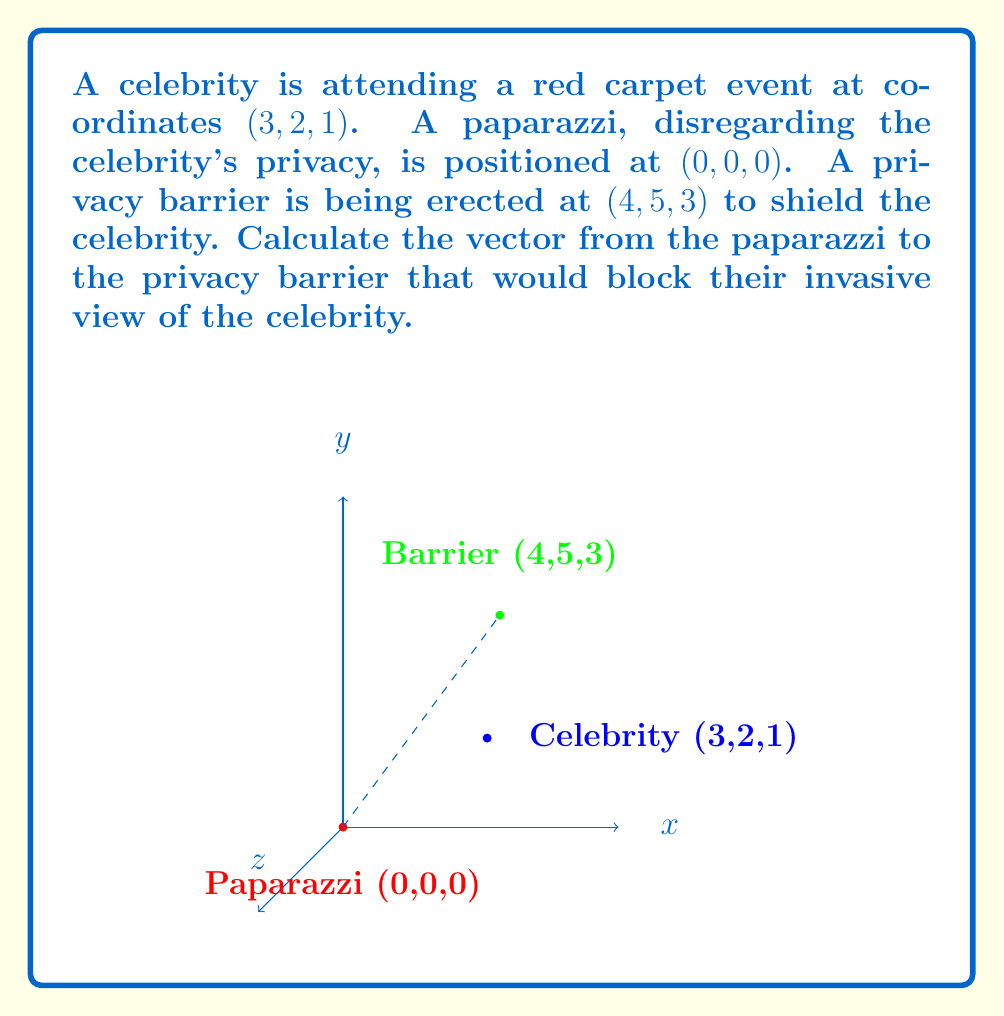Help me with this question. To find the vector from the paparazzi to the privacy barrier, we need to subtract the coordinates of the paparazzi's position from the barrier's position.

Given:
- Paparazzi position: $P(0, 0, 0)$
- Privacy barrier position: $B(4, 5, 3)$

The vector $\vec{PB}$ from the paparazzi to the barrier is calculated as follows:

$$\vec{PB} = B - P = (4-0, 5-0, 3-0)$$

Simplifying:

$$\vec{PB} = (4, 5, 3)$$

This vector represents the direction and magnitude of the path from the paparazzi to the privacy barrier. It's worth noting that this vector, when placed at the paparazzi's position, would indeed block their view of the celebrity, effectively protecting the celebrity's privacy.
Answer: $\vec{PB} = (4, 5, 3)$ 